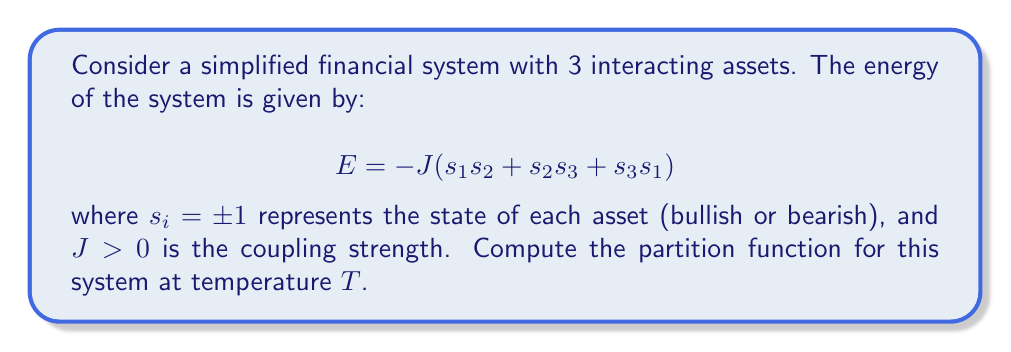Give your solution to this math problem. To compute the partition function, we follow these steps:

1) The partition function is defined as:
   $$Z = \sum_{\text{all states}} e^{-\beta E}$$
   where $\beta = \frac{1}{k_BT}$, $k_B$ is Boltzmann's constant, and $T$ is temperature.

2) In this system, there are 8 possible states: $(+++)$, $(++-)$, $(+-+)$, $(-++)$, $(+--)$, $(-+-)$, $(--+)$, and $(---)$.

3) Let's calculate the energy for each state:
   - For $(+++)$ and $(---)$: $E = -3J$
   - For $(++-)$, $(+-+)$, $(-++)$, $(+--)$, $(-+-)$, $(--+)$: $E = J$

4) Now, we can write out the partition function:
   $$Z = 2e^{3\beta J} + 6e^{-\beta J}$$

5) This can be factored as:
   $$Z = 2e^{3\beta J} + 6e^{-\beta J} = 2(e^{3\beta J} + 3e^{-\beta J})$$

This is the final form of the partition function for this system.
Answer: $Z = 2(e^{3\beta J} + 3e^{-\beta J})$ 